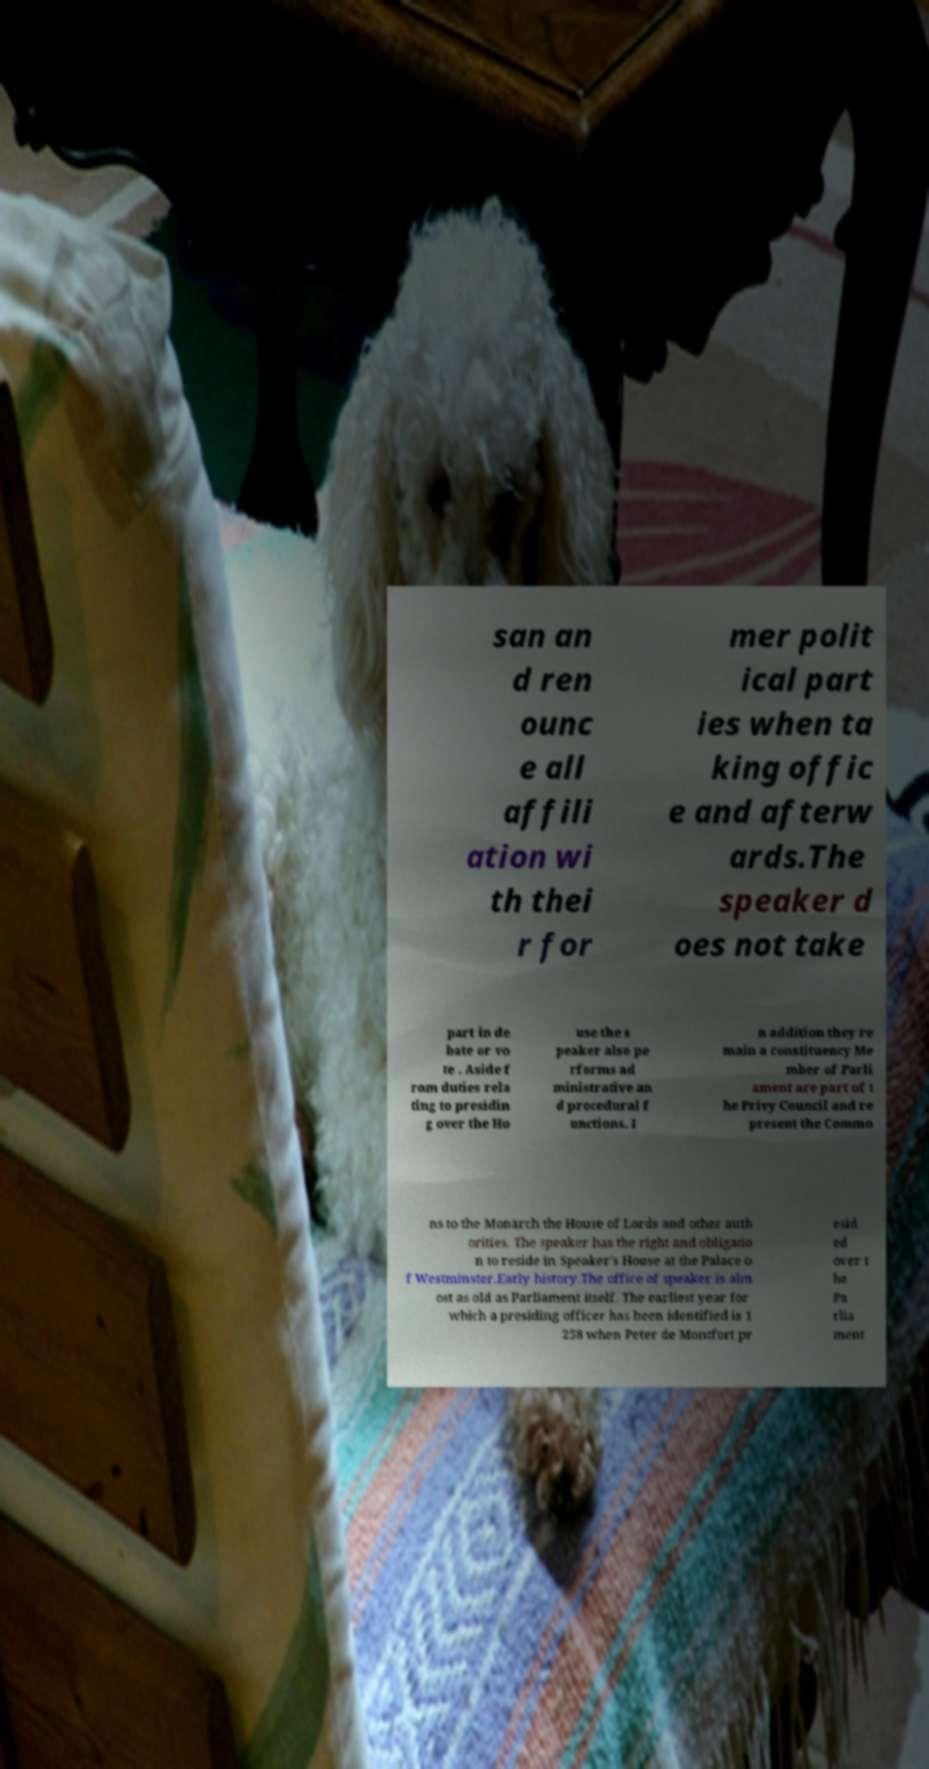Could you extract and type out the text from this image? san an d ren ounc e all affili ation wi th thei r for mer polit ical part ies when ta king offic e and afterw ards.The speaker d oes not take part in de bate or vo te . Aside f rom duties rela ting to presidin g over the Ho use the s peaker also pe rforms ad ministrative an d procedural f unctions. I n addition they re main a constituency Me mber of Parli ament are part of t he Privy Council and re present the Commo ns to the Monarch the House of Lords and other auth orities. The speaker has the right and obligatio n to reside in Speaker's House at the Palace o f Westminster.Early history.The office of speaker is alm ost as old as Parliament itself. The earliest year for which a presiding officer has been identified is 1 258 when Peter de Montfort pr esid ed over t he Pa rlia ment 